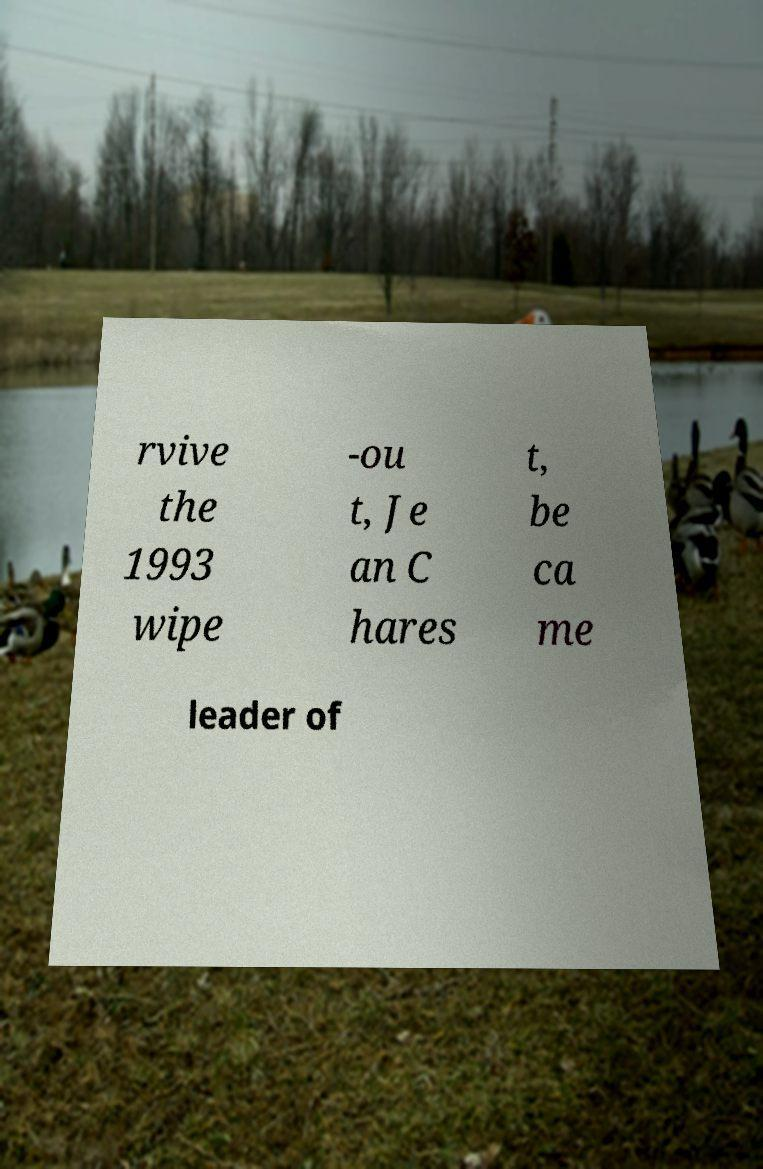Could you extract and type out the text from this image? rvive the 1993 wipe -ou t, Je an C hares t, be ca me leader of 